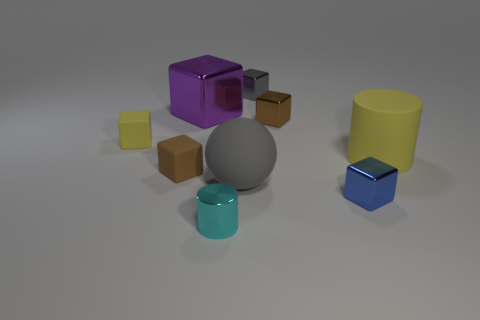What is the shape of the gray metal object that is the same size as the blue shiny cube?
Your response must be concise. Cube. What number of other things are there of the same color as the big shiny block?
Keep it short and to the point. 0. What is the size of the gray thing in front of the brown block that is behind the large yellow thing?
Your response must be concise. Large. Does the yellow object to the right of the big purple object have the same material as the sphere?
Keep it short and to the point. Yes. The big rubber object that is to the left of the big cylinder has what shape?
Keep it short and to the point. Sphere. How many metal cubes have the same size as the rubber ball?
Offer a very short reply. 1. What is the size of the yellow matte cube?
Provide a short and direct response. Small. What number of small brown objects are in front of the matte cylinder?
Offer a very short reply. 1. What shape is the cyan thing that is the same material as the large purple thing?
Offer a terse response. Cylinder. Is the number of tiny yellow cubes that are behind the yellow matte block less than the number of yellow rubber objects that are behind the small blue cube?
Provide a short and direct response. Yes. 